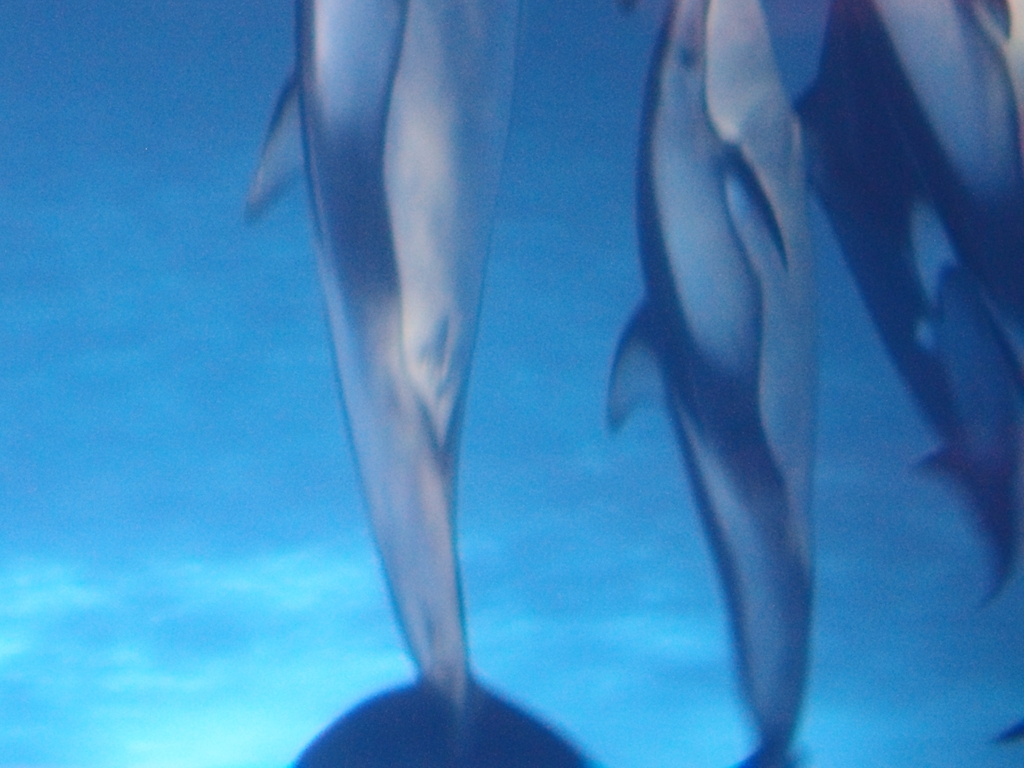Could you suggest what time of day this photo might have been taken? The lighting in the image is soft and diffuse, suggesting the photo may have been taken during the early morning or late afternoon when the sunlight is not as harsh and can penetrate the water to create a gentle illumination. What could the photographer do to improve images like this in the future? To improve similar photographs, the photographer could use a faster shutter speed to reduce the blurring effect on the swiftly moving subjects. Employing a higher resolution camera or using a lens with better underwater capabilities would also enhance the clarity and detail of the dolphins. 